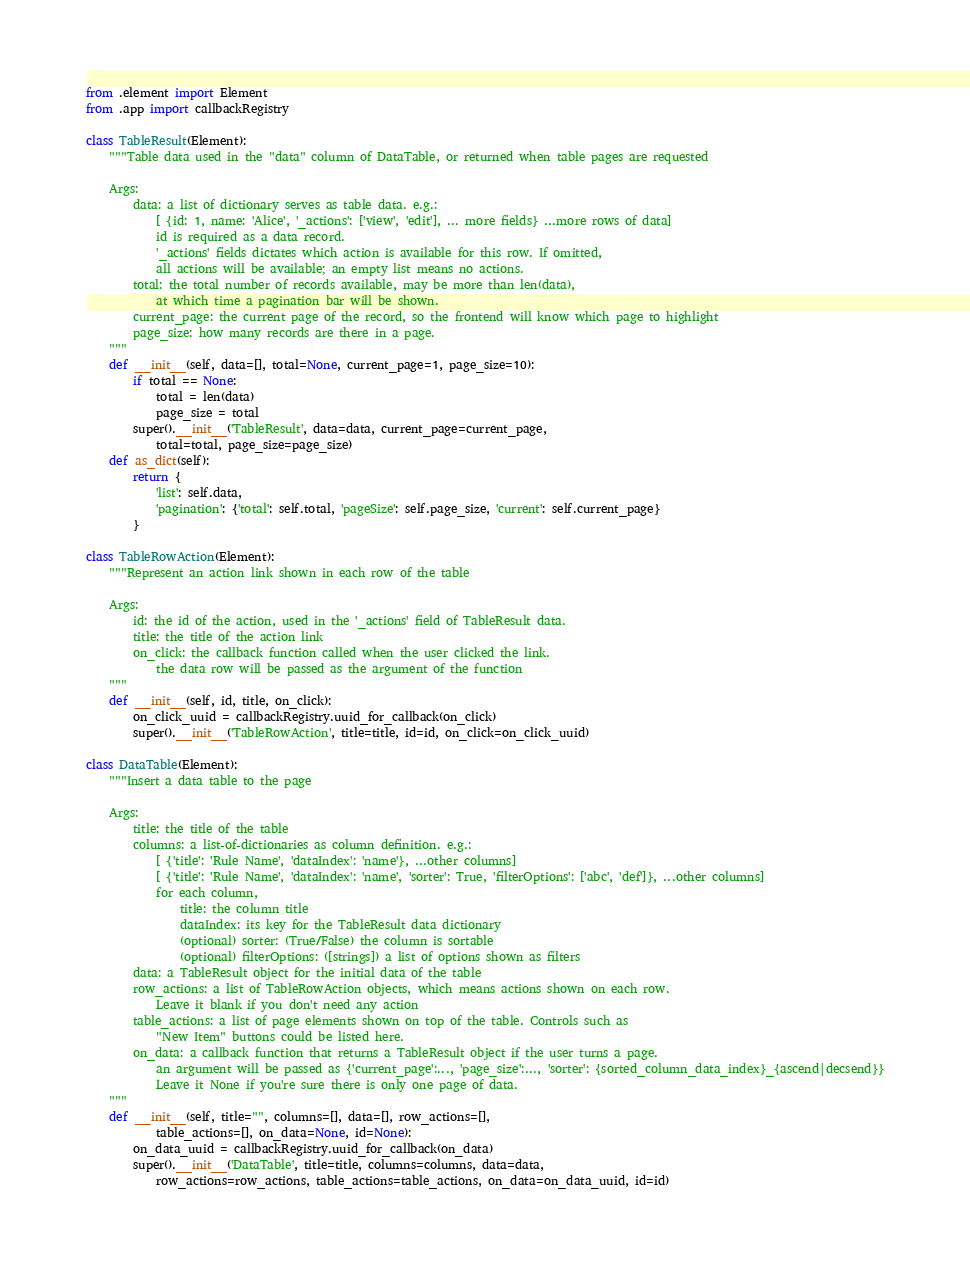<code> <loc_0><loc_0><loc_500><loc_500><_Python_>from .element import Element
from .app import callbackRegistry

class TableResult(Element):
    """Table data used in the "data" column of DataTable, or returned when table pages are requested
    
    Args:
        data: a list of dictionary serves as table data. e.g.:
            [ {id: 1, name: 'Alice', '_actions': ['view', 'edit'], ... more fields} ...more rows of data]
            id is required as a data record.
            '_actions' fields dictates which action is available for this row. If omitted, 
            all actions will be available; an empty list means no actions.
        total: the total number of records available, may be more than len(data), 
            at which time a pagination bar will be shown.
        current_page: the current page of the record, so the frontend will know which page to highlight
        page_size: how many records are there in a page.
    """
    def __init__(self, data=[], total=None, current_page=1, page_size=10):
        if total == None:
            total = len(data)
            page_size = total
        super().__init__('TableResult', data=data, current_page=current_page, 
            total=total, page_size=page_size)
    def as_dict(self):
        return {
            'list': self.data,
            'pagination': {'total': self.total, 'pageSize': self.page_size, 'current': self.current_page}
        }
        
class TableRowAction(Element):
    """Represent an action link shown in each row of the table
    
    Args:
        id: the id of the action, used in the '_actions' field of TableResult data.
        title: the title of the action link
        on_click: the callback function called when the user clicked the link.
            the data row will be passed as the argument of the function
    """
    def __init__(self, id, title, on_click):
        on_click_uuid = callbackRegistry.uuid_for_callback(on_click)
        super().__init__('TableRowAction', title=title, id=id, on_click=on_click_uuid)

class DataTable(Element):
    """Insert a data table to the page
    
    Args:
        title: the title of the table
        columns: a list-of-dictionaries as column definition. e.g.:
            [ {'title': 'Rule Name', 'dataIndex': 'name'}, ...other columns]
            [ {'title': 'Rule Name', 'dataIndex': 'name', 'sorter': True, 'filterOptions': ['abc', 'def']}, ...other columns]
            for each column, 
                title: the column title
                dataIndex: its key for the TableResult data dictionary
                (optional) sorter: (True/False) the column is sortable
                (optional) filterOptions: ([strings]) a list of options shown as filters
        data: a TableResult object for the initial data of the table
        row_actions: a list of TableRowAction objects, which means actions shown on each row.
            Leave it blank if you don't need any action
        table_actions: a list of page elements shown on top of the table. Controls such as
            "New Item" buttons could be listed here.
        on_data: a callback function that returns a TableResult object if the user turns a page.
            an argument will be passed as {'current_page':..., 'page_size':..., 'sorter': {sorted_column_data_index}_{ascend|decsend}}
            Leave it None if you're sure there is only one page of data.
    """
    def __init__(self, title="", columns=[], data=[], row_actions=[],
            table_actions=[], on_data=None, id=None):
        on_data_uuid = callbackRegistry.uuid_for_callback(on_data)
        super().__init__('DataTable', title=title, columns=columns, data=data,
            row_actions=row_actions, table_actions=table_actions, on_data=on_data_uuid, id=id)

</code> 